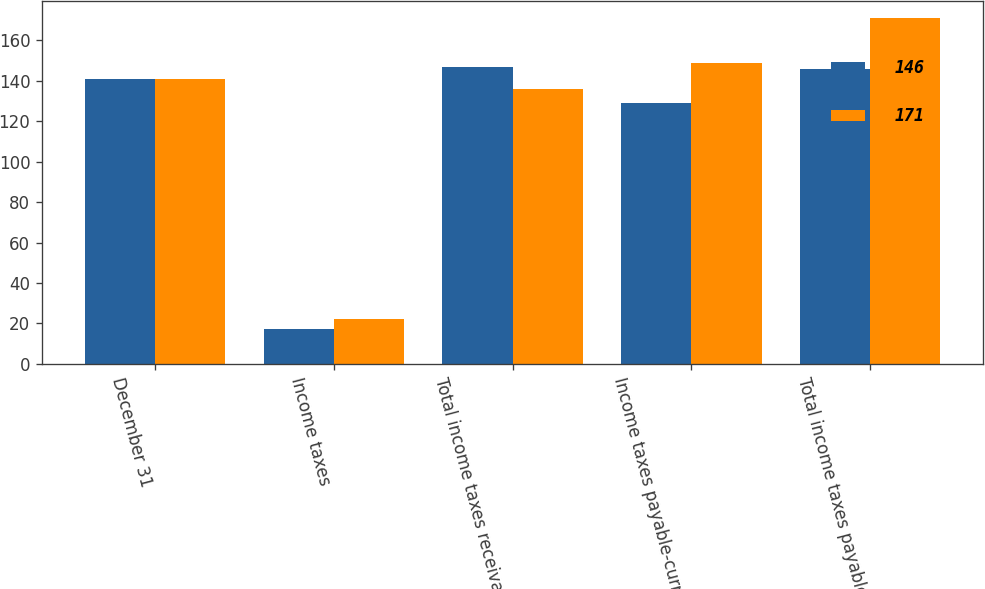<chart> <loc_0><loc_0><loc_500><loc_500><stacked_bar_chart><ecel><fcel>December 31<fcel>Income taxes<fcel>Total income taxes receivable<fcel>Income taxes payable-current<fcel>Total income taxes payable<nl><fcel>146<fcel>141<fcel>17<fcel>147<fcel>129<fcel>146<nl><fcel>171<fcel>141<fcel>22<fcel>136<fcel>149<fcel>171<nl></chart> 